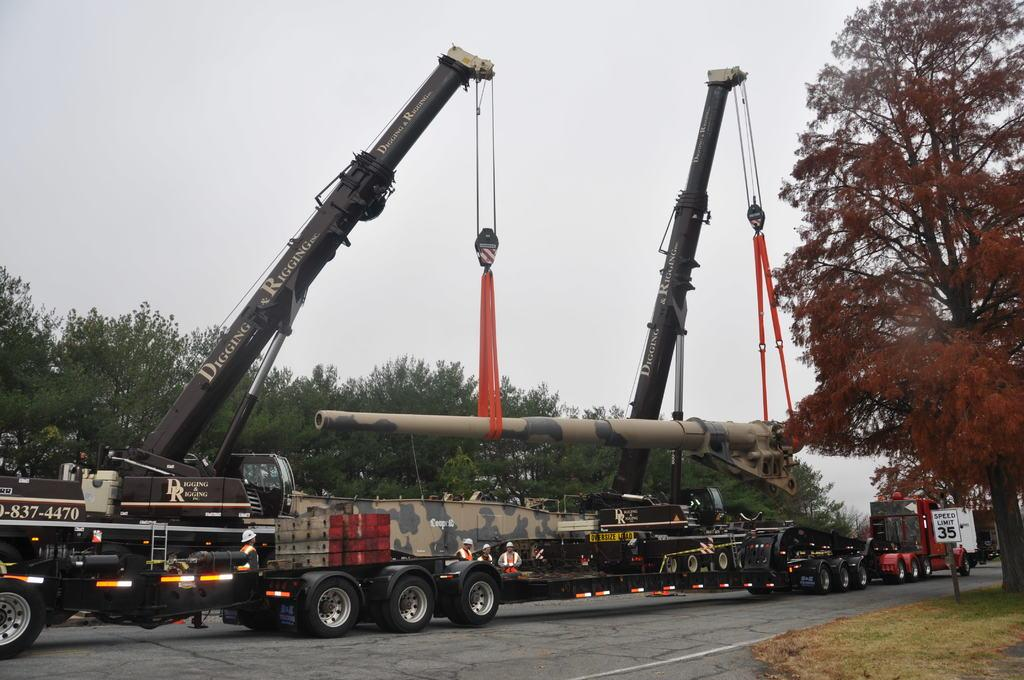What can be seen in the image? There are vehicles and people wearing caps in the image. What else is visible on the road? There are lights on the road. What can be seen in the background of the image? There are trees and a board visible in the background. What is visible at the top of the image? The sky is visible at the top of the image. How many clovers are growing on the road in the image? There are no clovers visible on the road in the image. What type of country is depicted in the background of the image? The image does not depict a country; it shows a board and trees in the background. 